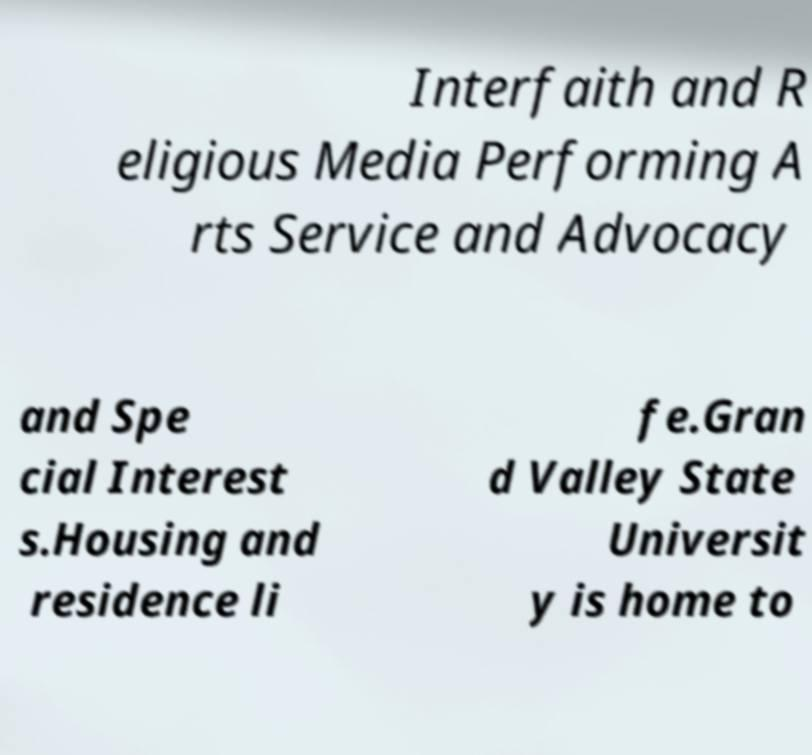There's text embedded in this image that I need extracted. Can you transcribe it verbatim? Interfaith and R eligious Media Performing A rts Service and Advocacy and Spe cial Interest s.Housing and residence li fe.Gran d Valley State Universit y is home to 